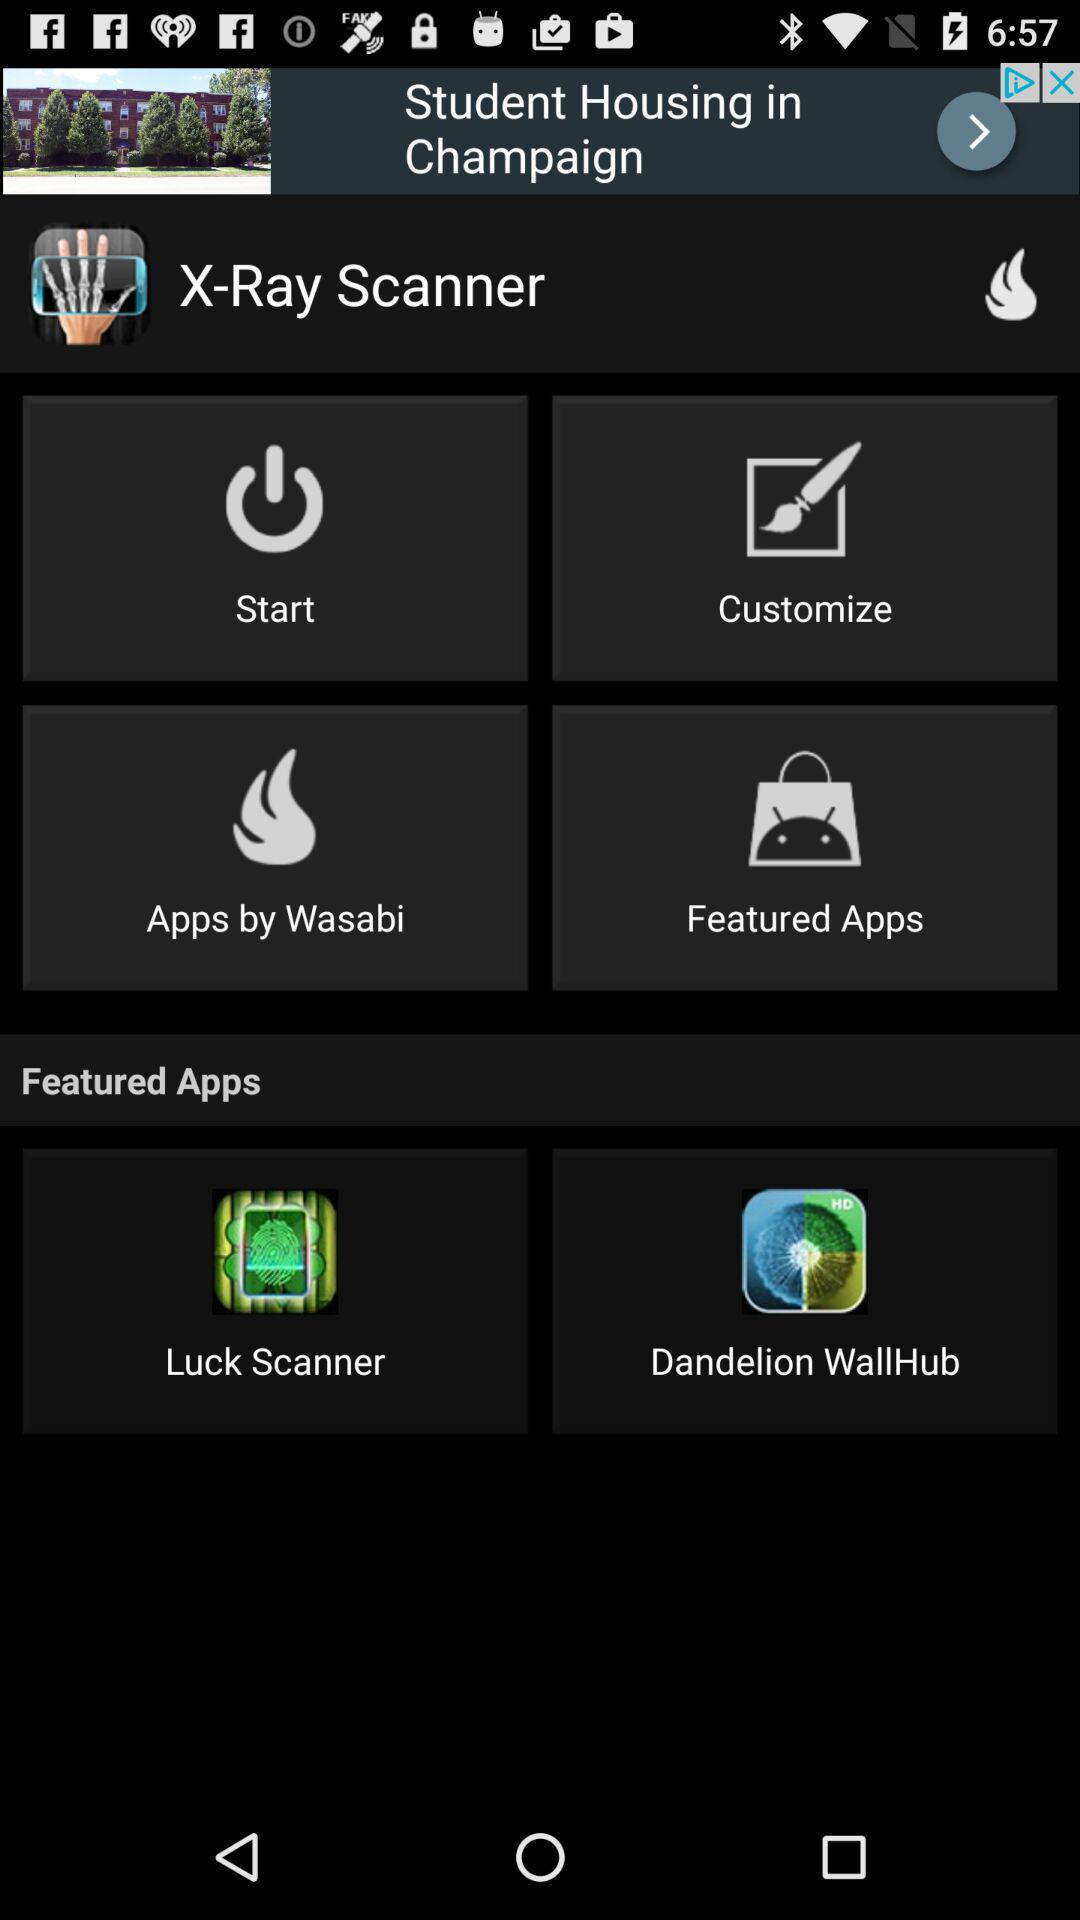What are the "Featured Apps"? The apps are "Luck Scanner" and "Dandelion WallHub". 